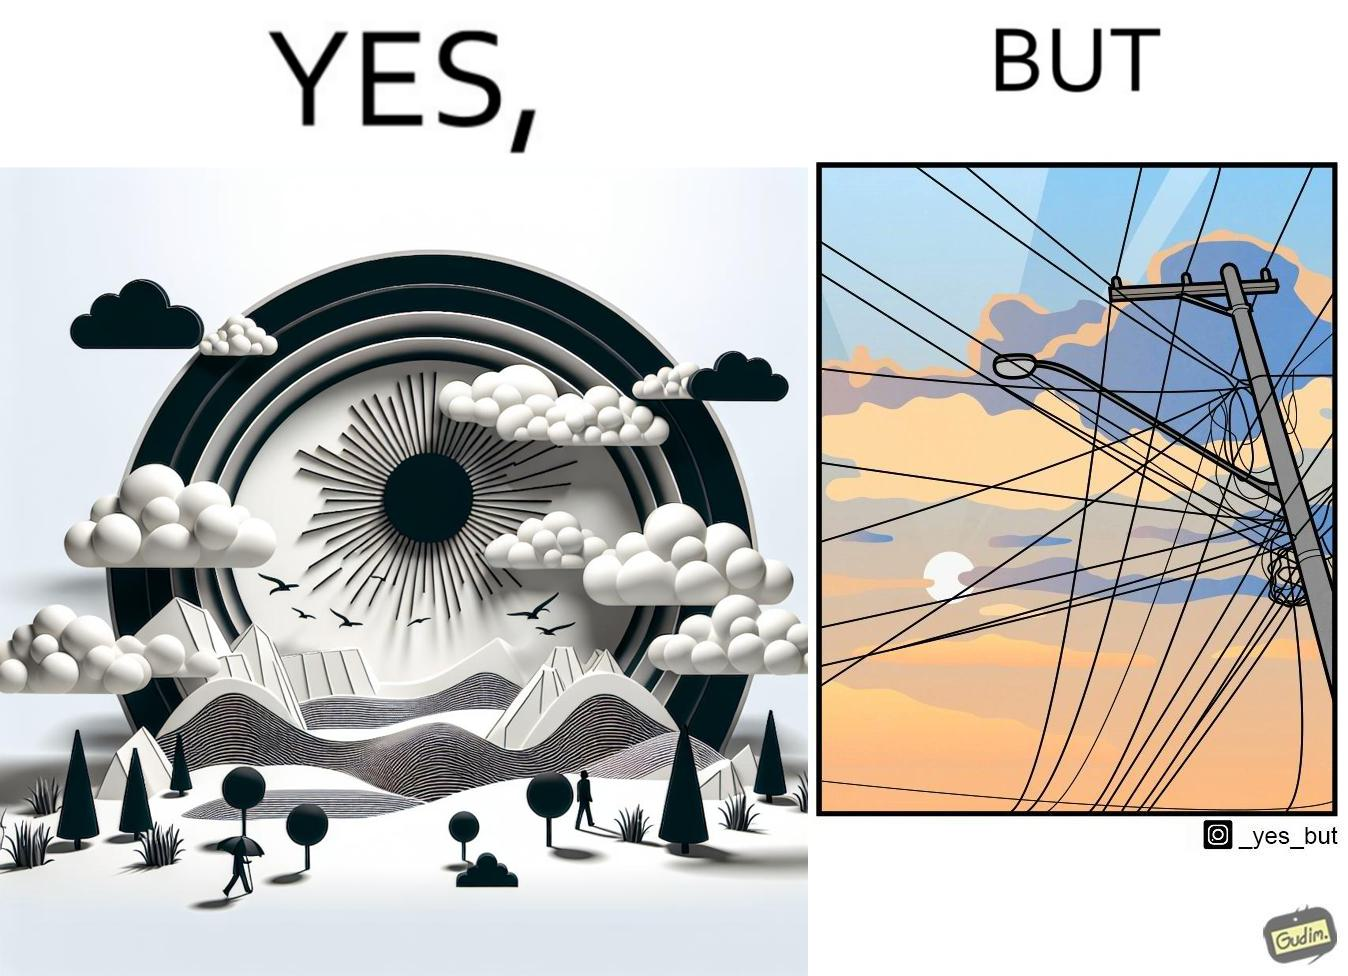What makes this image funny or satirical? The image is ironic, because in the first image clear sky is visible but in the second image the same view is getting blocked due to the electricity pole 